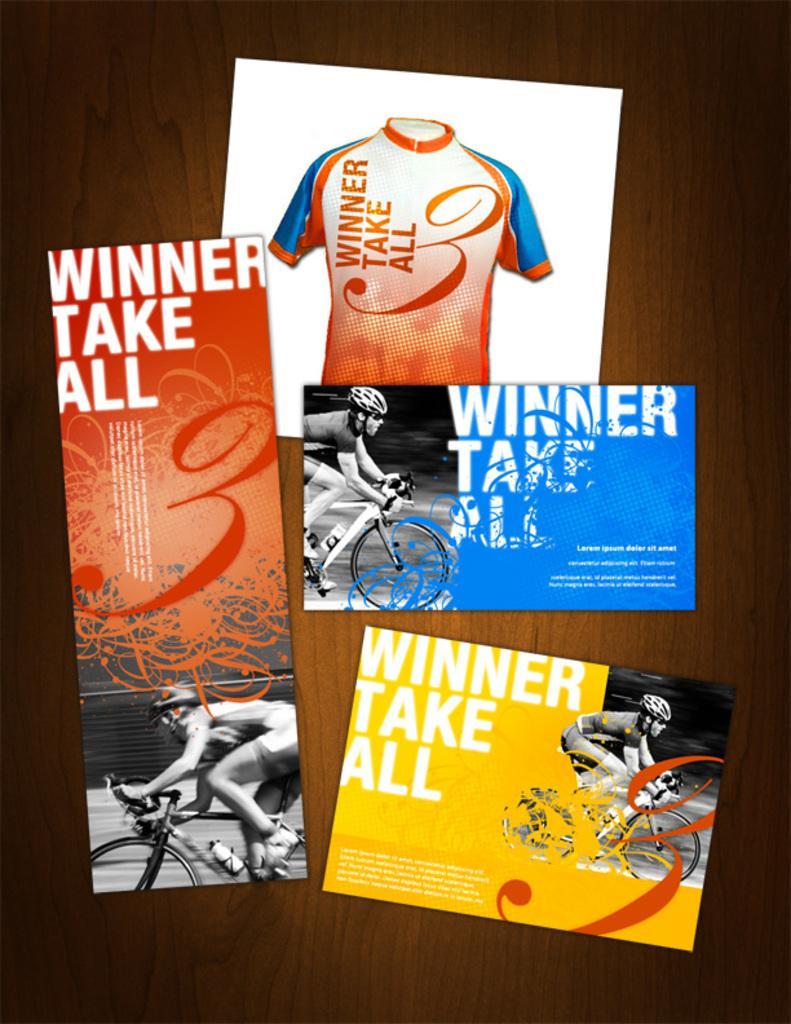In one or two sentences, can you explain what this image depicts? In this image, we can see a flyer contains a person riding a bicycle, t-shirt and some text. 